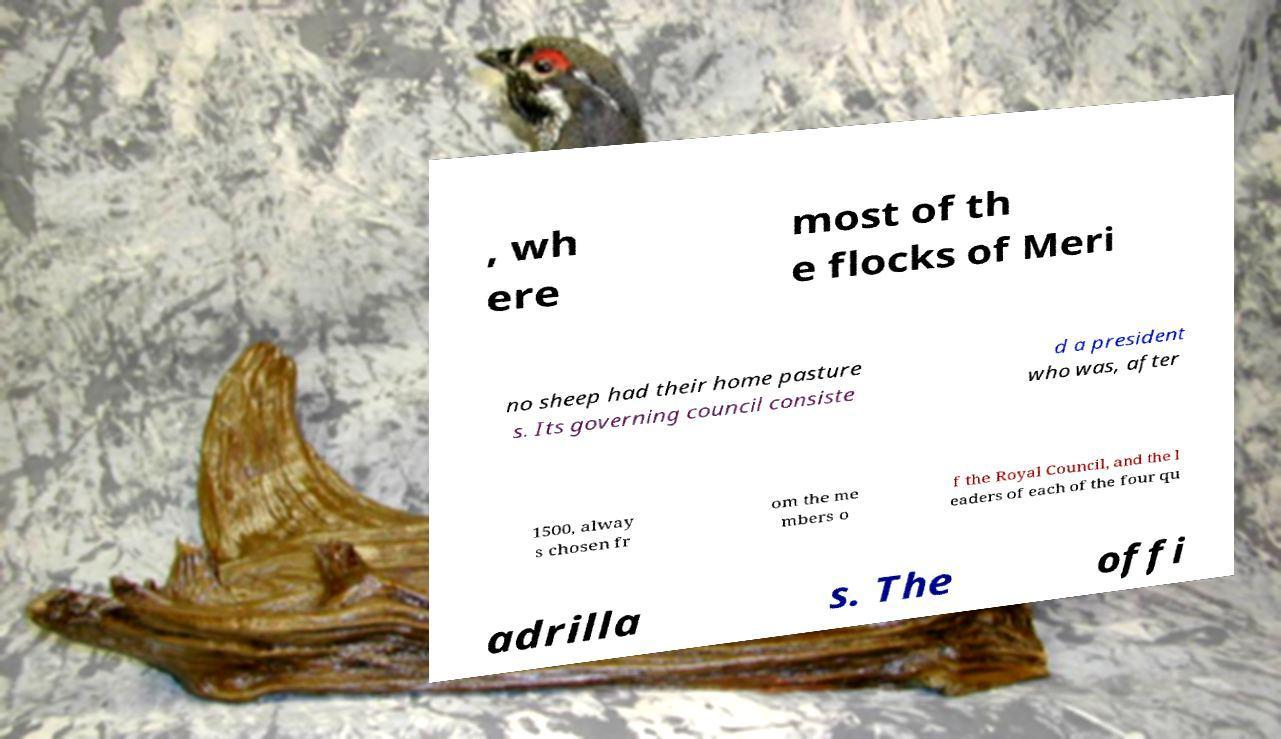Please read and relay the text visible in this image. What does it say? , wh ere most of th e flocks of Meri no sheep had their home pasture s. Its governing council consiste d a president who was, after 1500, alway s chosen fr om the me mbers o f the Royal Council, and the l eaders of each of the four qu adrilla s. The offi 